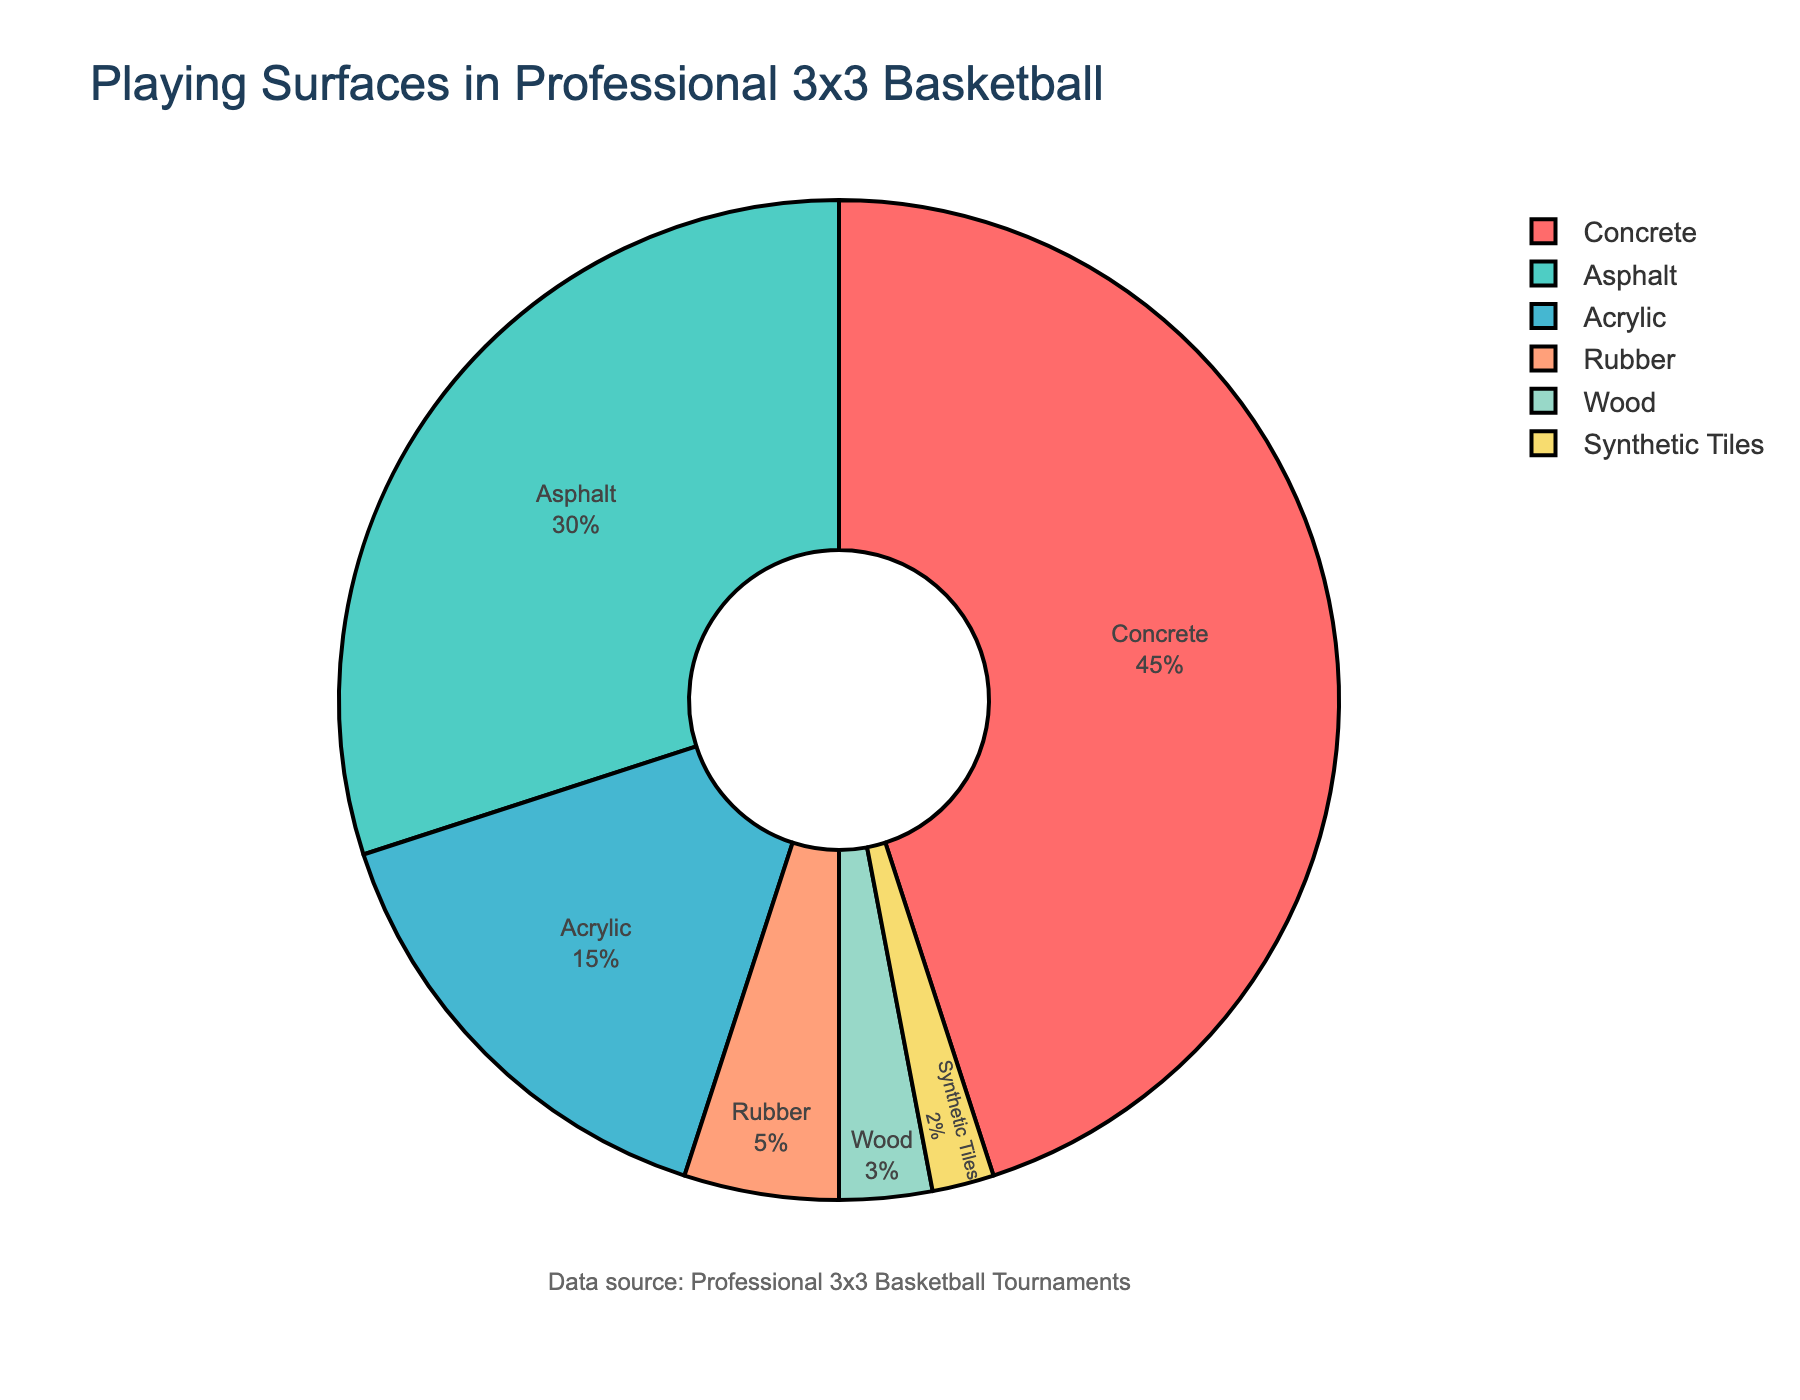What's the most common playing surface used in professional 3x3 basketball tournaments? According to the pie chart, the largest section corresponds to concrete.
Answer: Concrete Which playing surface is used more: rubber or wood? By observing the pie chart, the rubber section is larger than the wood section.
Answer: Rubber What is the combined percentage of tournaments played on acrylic and asphalt? Add the percentages for acrylic and asphalt: 15% + 30%.
Answer: 45% What's the difference in percentage between the most common and the least common playing surfaces? Subtract the percentage of synthetic tiles from concrete: 45% - 2%.
Answer: 43% List all the playing surfaces that together make up less than 10% of the tournaments. The pie chart shows that wood (3%) and synthetic tiles (2%) both fall below 10%. Summing them confirms they are 5% in total, less than 10%.
Answer: Wood, Synthetic Tiles Which surface type is depicted in blue? By visually identifying the color blue, it corresponds to Asphalt on the pie chart.
Answer: Asphalt What are the surface types that together make up exactly half of all surfaces used? Add percentages of the largest surfaces until the total reaches 50%: Concrete (45%) + Synthetic Tiles (2%) + Wood (3%) = 50%.
Answer: Concrete, Synthetic Tiles, Wood How much greater is the usage of asphalt compared to synthetic tiles? Subtract the percentage of synthetic tiles from asphalt: 30% - 2%.
Answer: 28% If a new surface type called “Grass” is introduced and takes 10% share, what percentage will Concrete hold then? Subtract 10% from Concrete's original 45% to accommodate for Grass: 45% - 10%.
Answer: 35% Which surface types combined hold a higher percentage than Concrete alone? Add Asphalt (30%) and Acrylic (15%) to see that these combined exceed Concrete: 30% + 15% = 45%.
Answer: Asphalt, Acrylic 